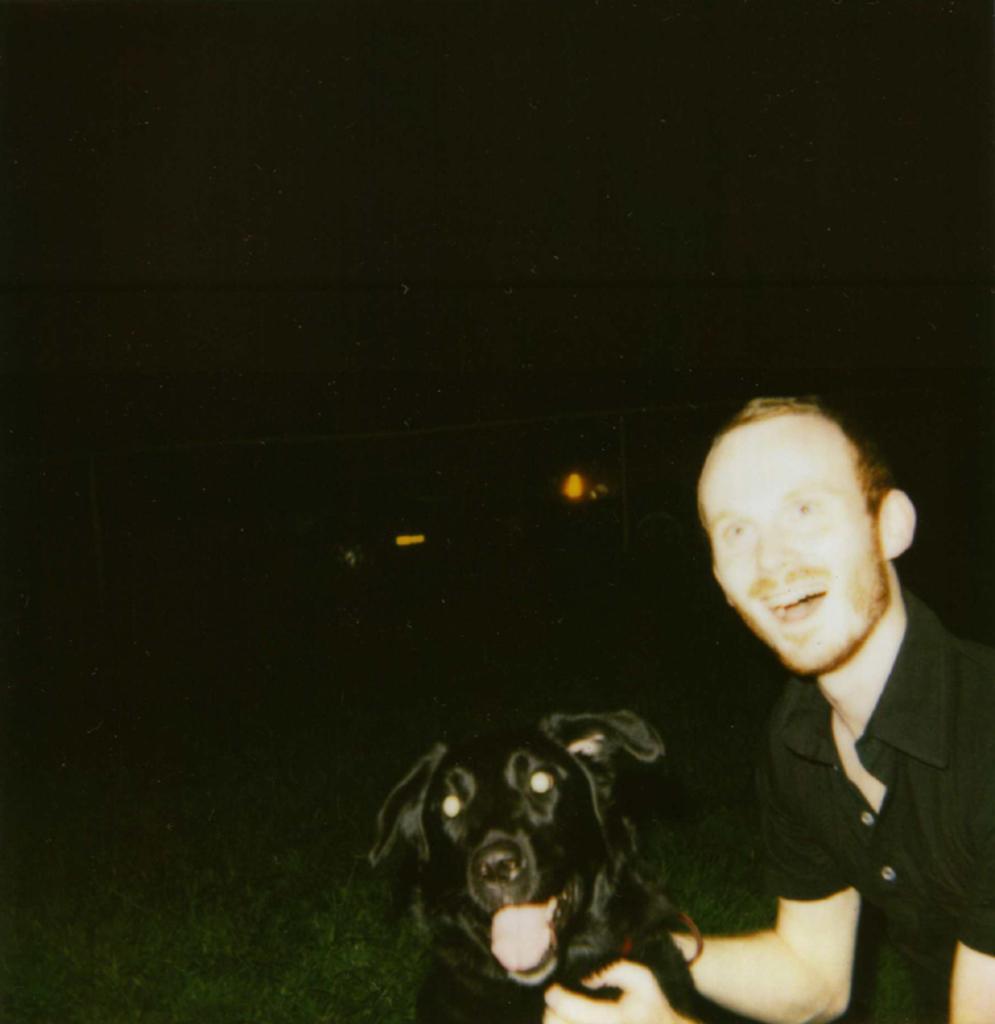How would you summarize this image in a sentence or two? This image is taken outside. In the right side of the image there is a man playing with a dog. In the middle of the image there is a dog. In the left side of the image there is a grass. 